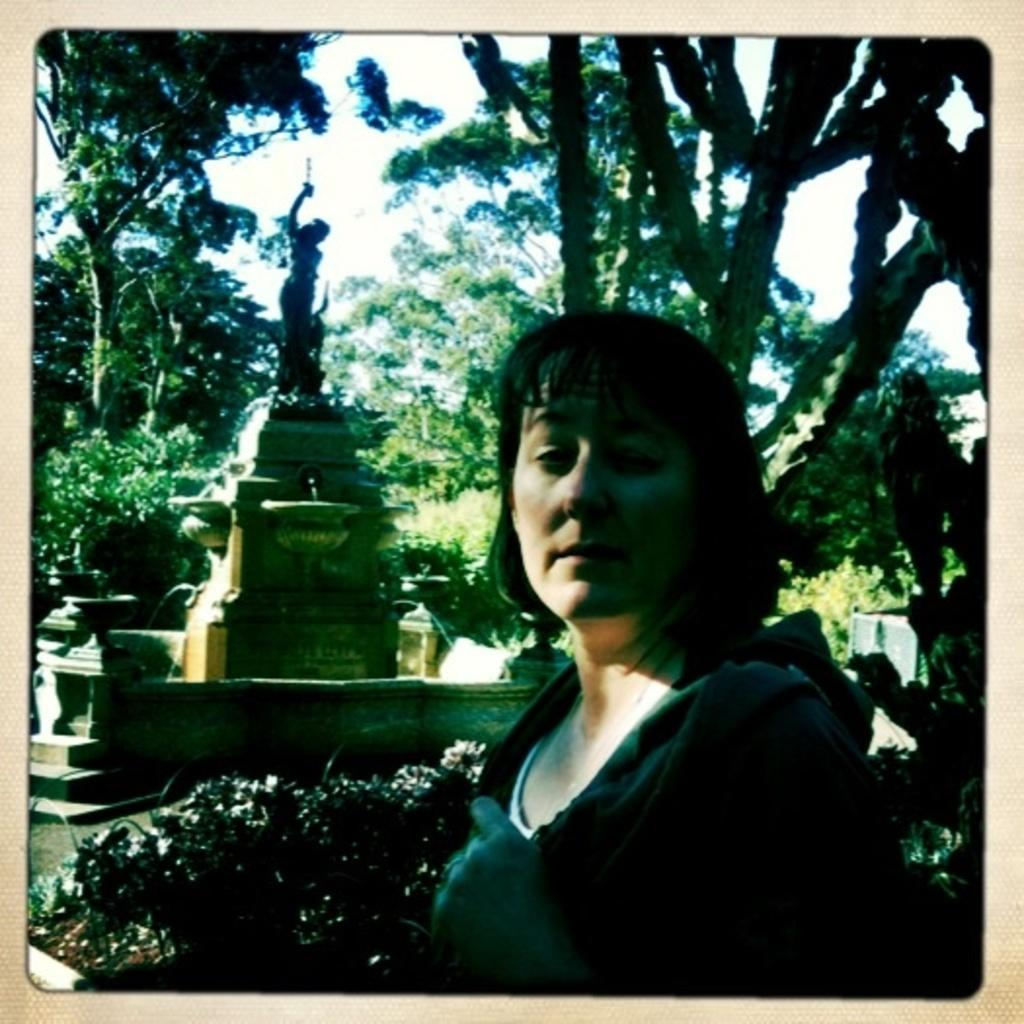Who is the main subject in the image? There is a woman in the middle of the image. What can be seen in the background of the image? There are trees, plants, and a statue in the background of the image. What is visible at the top of the image? The sky is visible at the top of the image. What type of lock can be seen on the woman's finger in the image? There is no lock present on the woman's finger in the image. What time of day is depicted in the image? The time of day cannot be determined from the image, as there is no specific information about lighting or shadows. 